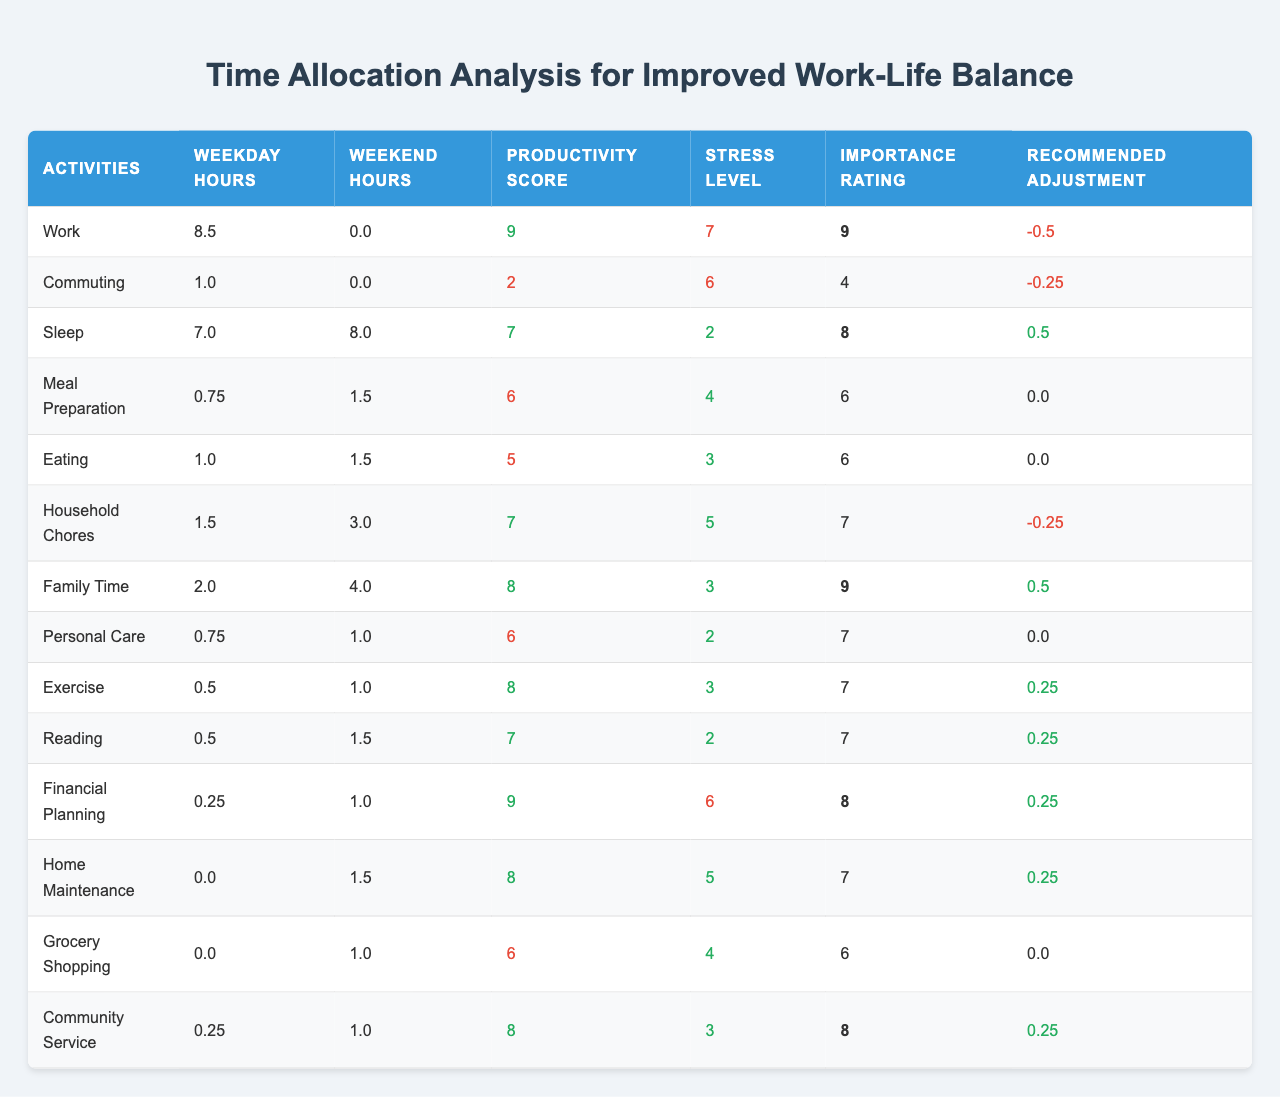What is the productivity score for "Exercise"? Referring to the table, the productivity score for "Exercise" is 8.
Answer: 8 Which activity has the highest importance rating? Looking at the table, "Work", "Family Time", and "Community Service" all have the highest importance rating of 9.
Answer: Work, Family Time, Community Service How many total hours are allocated for "Household Chores" on the weekend? From the table, "Household Chores" has 3.0 hours allocated on the weekend.
Answer: 3.0 What is the average weekday hour allocation across all activities? By summing the weekday hours (8.5 + 1.0 + 7.0 + 0.75 + 1.0 + 1.5 + 2.0 + 0.75 + 0.5 + 0.5 + 0.25 + 0.0 + 0.0 + 0.25) = 24.0 and dividing by the number of activities (14), the average is 24.0/14 ≈ 1.71.
Answer: Approximately 1.71 Is the stress level for "Commuting" higher than that for "Meal Preparation"? The stress level for "Commuting" is 6, and for "Meal Preparation" it is 4, so yes, "Commuting" has a higher stress level.
Answer: Yes Which activity should be adjusted the most based on the recommended adjustments? Reviewing the recommended adjustments, "Work" has the largest negative adjustment of -0.5 hours, indicating it should be adjusted the most.
Answer: Work What is the total time allocated for family-related activities (Family Time and Meal Preparation) on weekdays? Adding the weekday hours for "Family Time" (2.0) and "Meal Preparation" (0.75), the total time is 2.0 + 0.75 = 2.75 hours.
Answer: 2.75 How does the productivity score for "Grocery Shopping" compare to "Financial Planning"? The productivity score for "Grocery Shopping" is 6, while for "Financial Planning" it is 9. Since 6 is less than 9, "Grocery Shopping" has a lower productivity score.
Answer: Lower If the recommended adjustment is made for "Personal Care", what will its new weekday hour allocation be? The current weekday hour allocation for "Personal Care" is 0.75, and with the recommended adjustment of 0.0, it will remain at 0.75 hours.
Answer: 0.75 Which activity has the lowest stress level and what is that level? "Sleep" has the lowest stress level of 2.
Answer: 2 